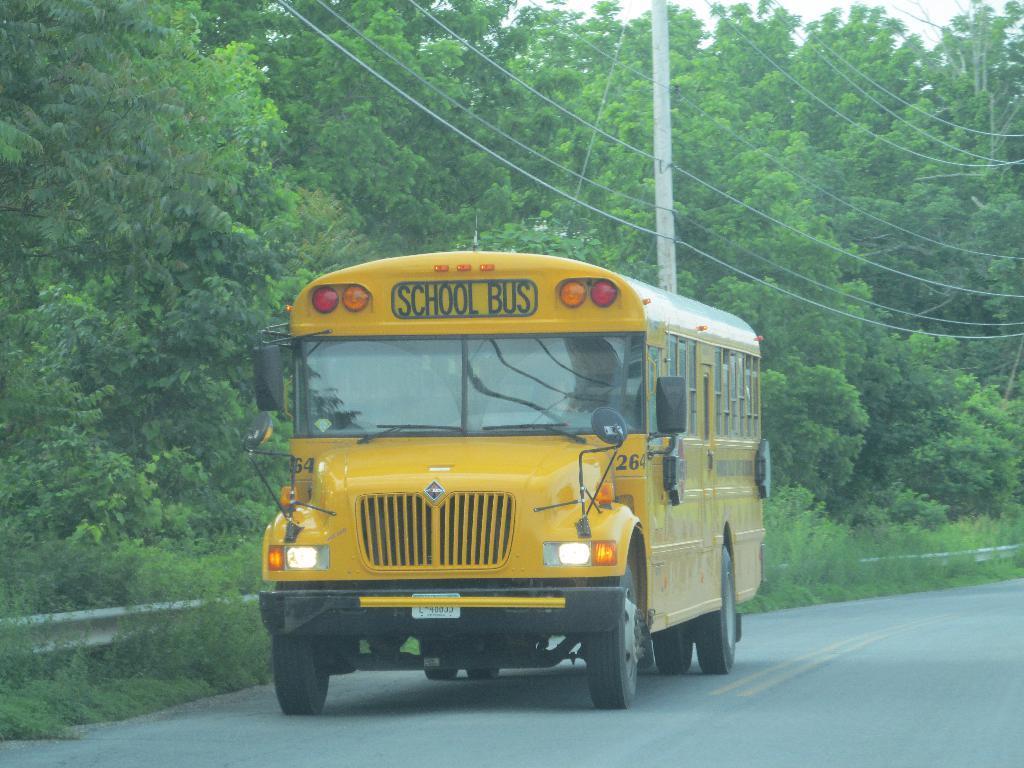Could you give a brief overview of what you see in this image? In the middle of the picture, the bus in yellow color is moving on the road. At the bottom of the picture, we see the road. On the left side, we see grass and trees. In the background, we see electric poles, wires and trees. 